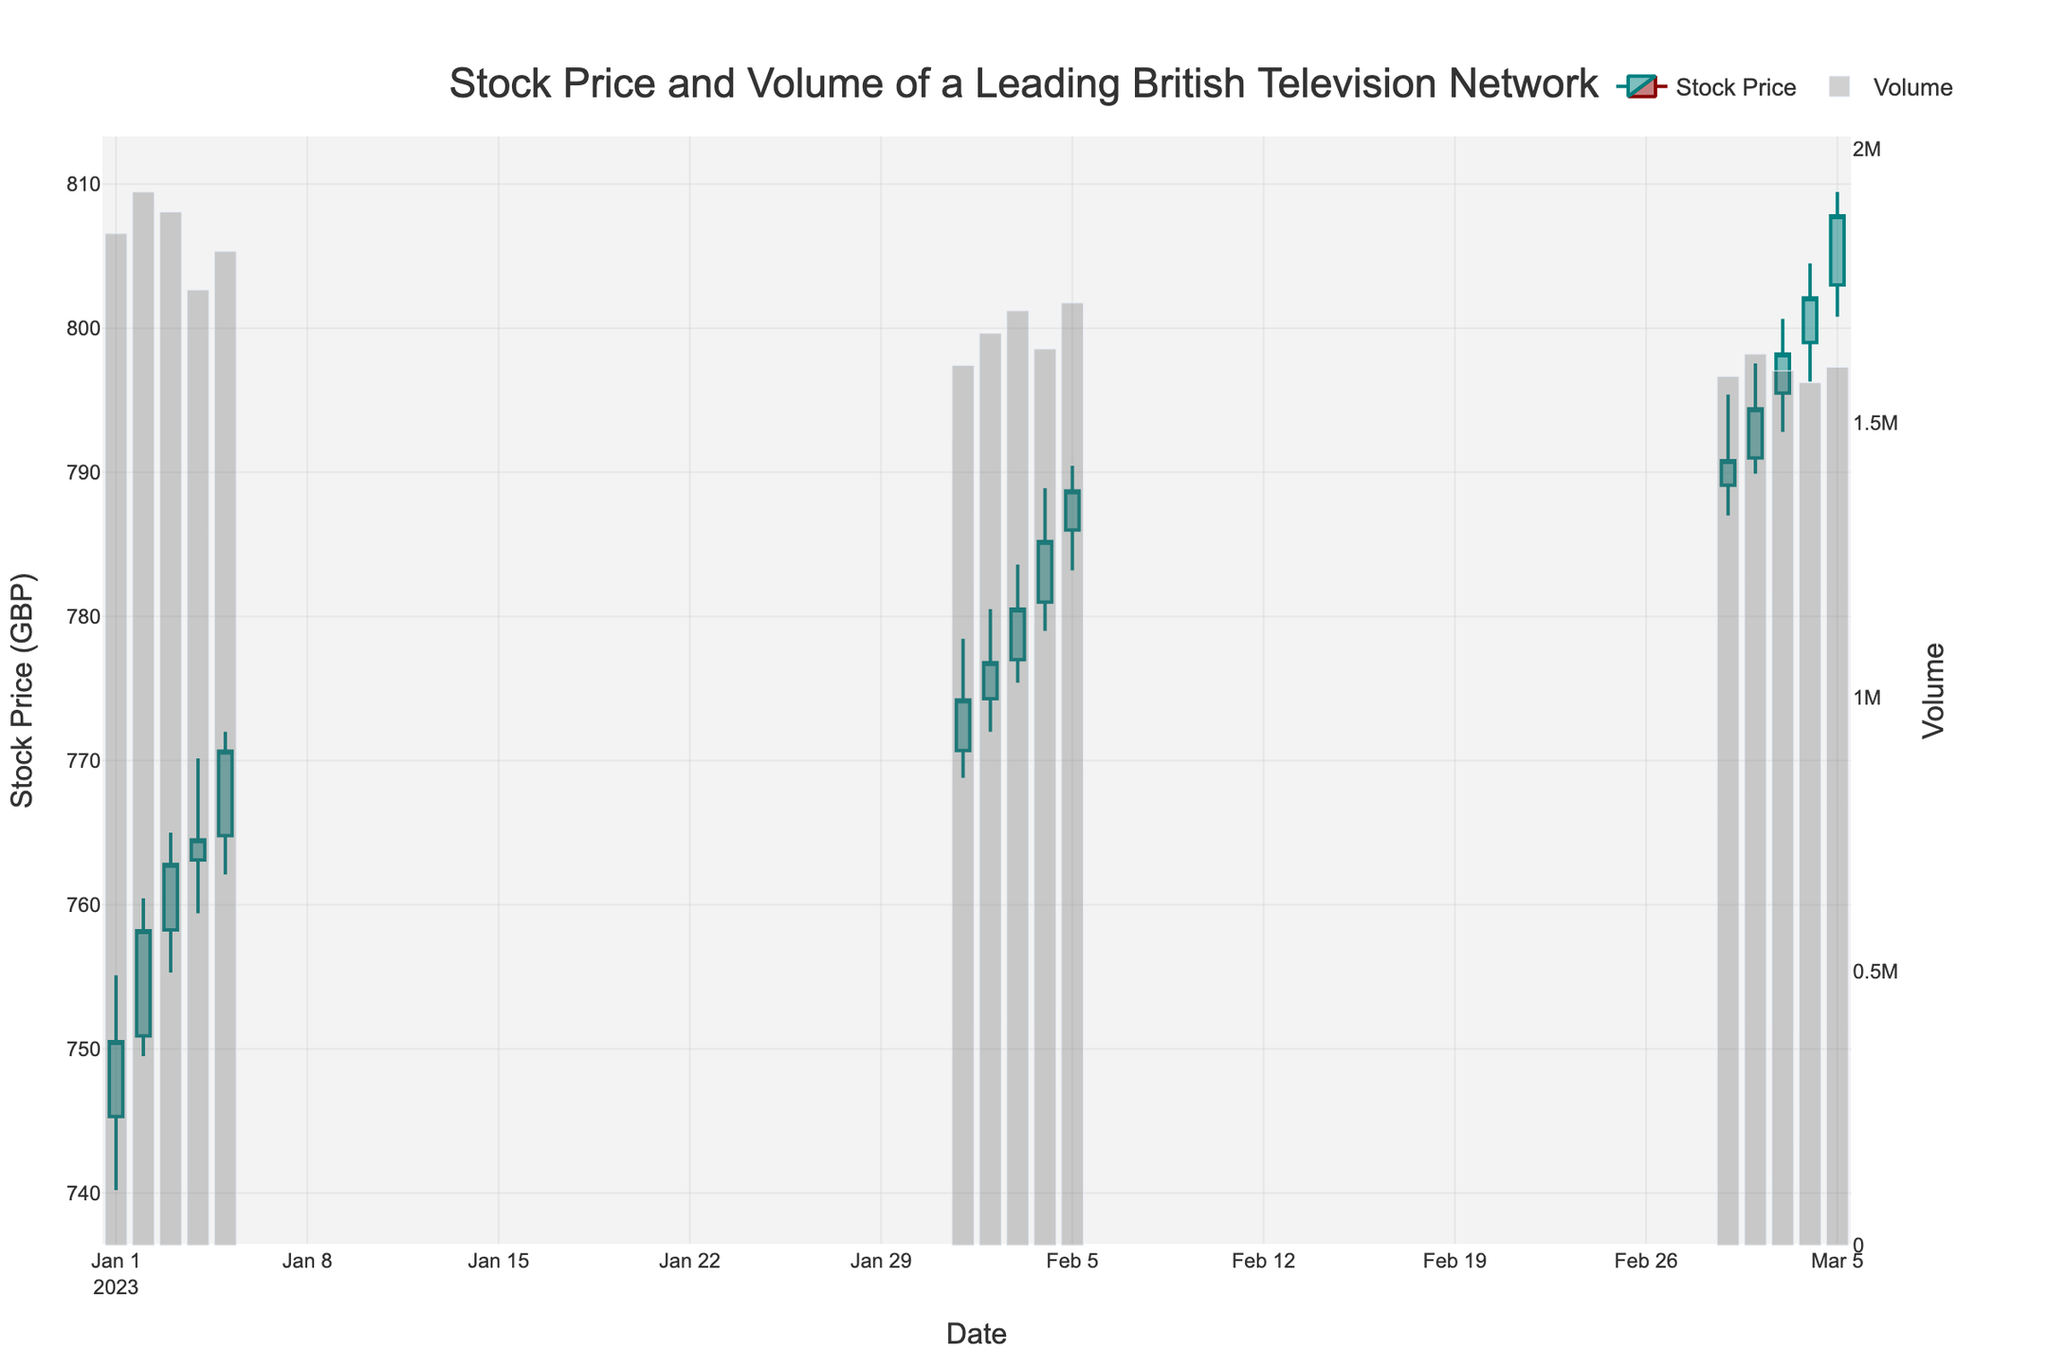What's the title of the plot? The title of the plot is always displayed at the top of the figure. In this case, it reads "Stock Price and Volume of a Leading British Television Network."
Answer: Stock Price and Volume of a Leading British Television Network What are the colors used to represent increasing and decreasing stock prices? The colors of the lines representing increasing and decreasing stock prices can be discerned by looking at the candlestick plot. Increasing prices are shown in a teal-like color, while decreasing prices are shown in a dark red color.
Answer: Increasing: teal, Decreasing: dark red How many days does the candlestick plot data cover? To determine the number of days the data covers, we can count the number of unique dates on the x-axis, which shows each individual day. In this case, there are 15 dates shown on the x-axis, covering a span from January to March.
Answer: 15 days What's the highest stock price recorded in February? To find the highest stock price in February, look at the highest points of the candlesticks within the February date range (February 1-5). The highest price is shown at the top of the candlestick on February 5, which reaches 790.45.
Answer: 790.45 What is the average closing price in March? To find the average closing price in March, sum the closing prices for each day in March (790.80, 794.40, 798.20, 802.10, 807.80), then divide by the number of days (5). The total is 3993.30, and dividing by 5 gives an average of 798.66.
Answer: 798.66 Which day in January had the highest trading volume? To determine the day with the highest trading volume in January, look at the bar representing volume for each day in January (1-5) and identify the highest bar. January 2 had the highest trading volume of 1,921,000 units.
Answer: January 2 Compare the closing prices at the end of February and the beginning of March. Which was higher? The closing price at the end of February (February 5) was 788.70. The closing price at the beginning of March (March 1) was 790.80. Comparing these, the closing price at the beginning of March was higher.
Answer: March 1 What is the range of stock prices on February 4? The range is the difference between the high and low prices on February 4. The high was 788.90, and the low was 779.00. Subtracting these gives a range of 9.90.
Answer: 9.90 On which date did the stock price close just below 800 GBP for the first time? Identify the candlestick plot where the closing price approaches but is below 800 GBP. On March 3, the closing price was 798.20, which is just below the 800 GBP mark.
Answer: March 3 